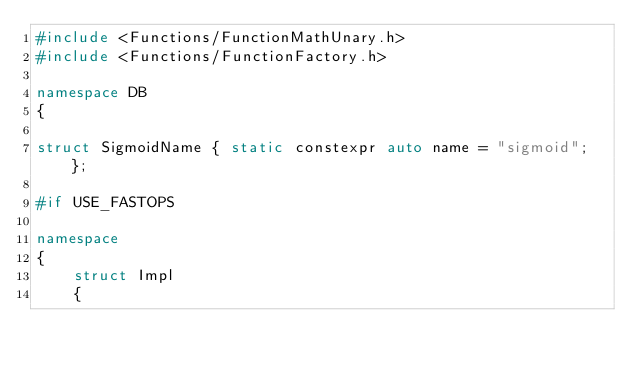<code> <loc_0><loc_0><loc_500><loc_500><_C++_>#include <Functions/FunctionMathUnary.h>
#include <Functions/FunctionFactory.h>

namespace DB
{

struct SigmoidName { static constexpr auto name = "sigmoid"; };

#if USE_FASTOPS

namespace
{
    struct Impl
    {</code> 